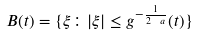Convert formula to latex. <formula><loc_0><loc_0><loc_500><loc_500>B ( t ) = \{ \xi \colon | \xi | \leq g ^ { - \frac { 1 } { 2 \ a } } ( t ) \}</formula> 